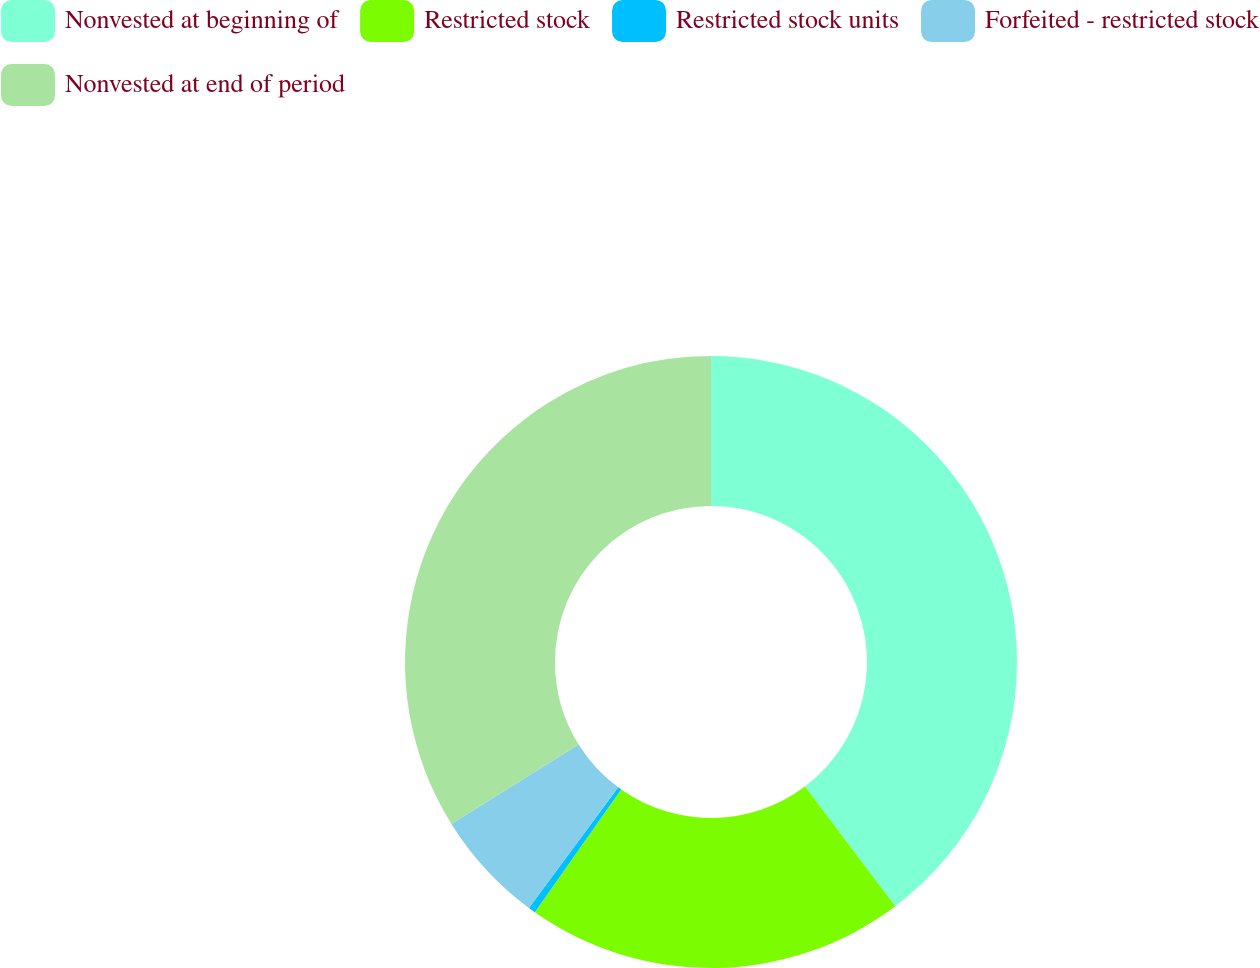<chart> <loc_0><loc_0><loc_500><loc_500><pie_chart><fcel>Nonvested at beginning of<fcel>Restricted stock<fcel>Restricted stock units<fcel>Forfeited - restricted stock<fcel>Nonvested at end of period<nl><fcel>39.72%<fcel>20.05%<fcel>0.38%<fcel>5.98%<fcel>33.88%<nl></chart> 